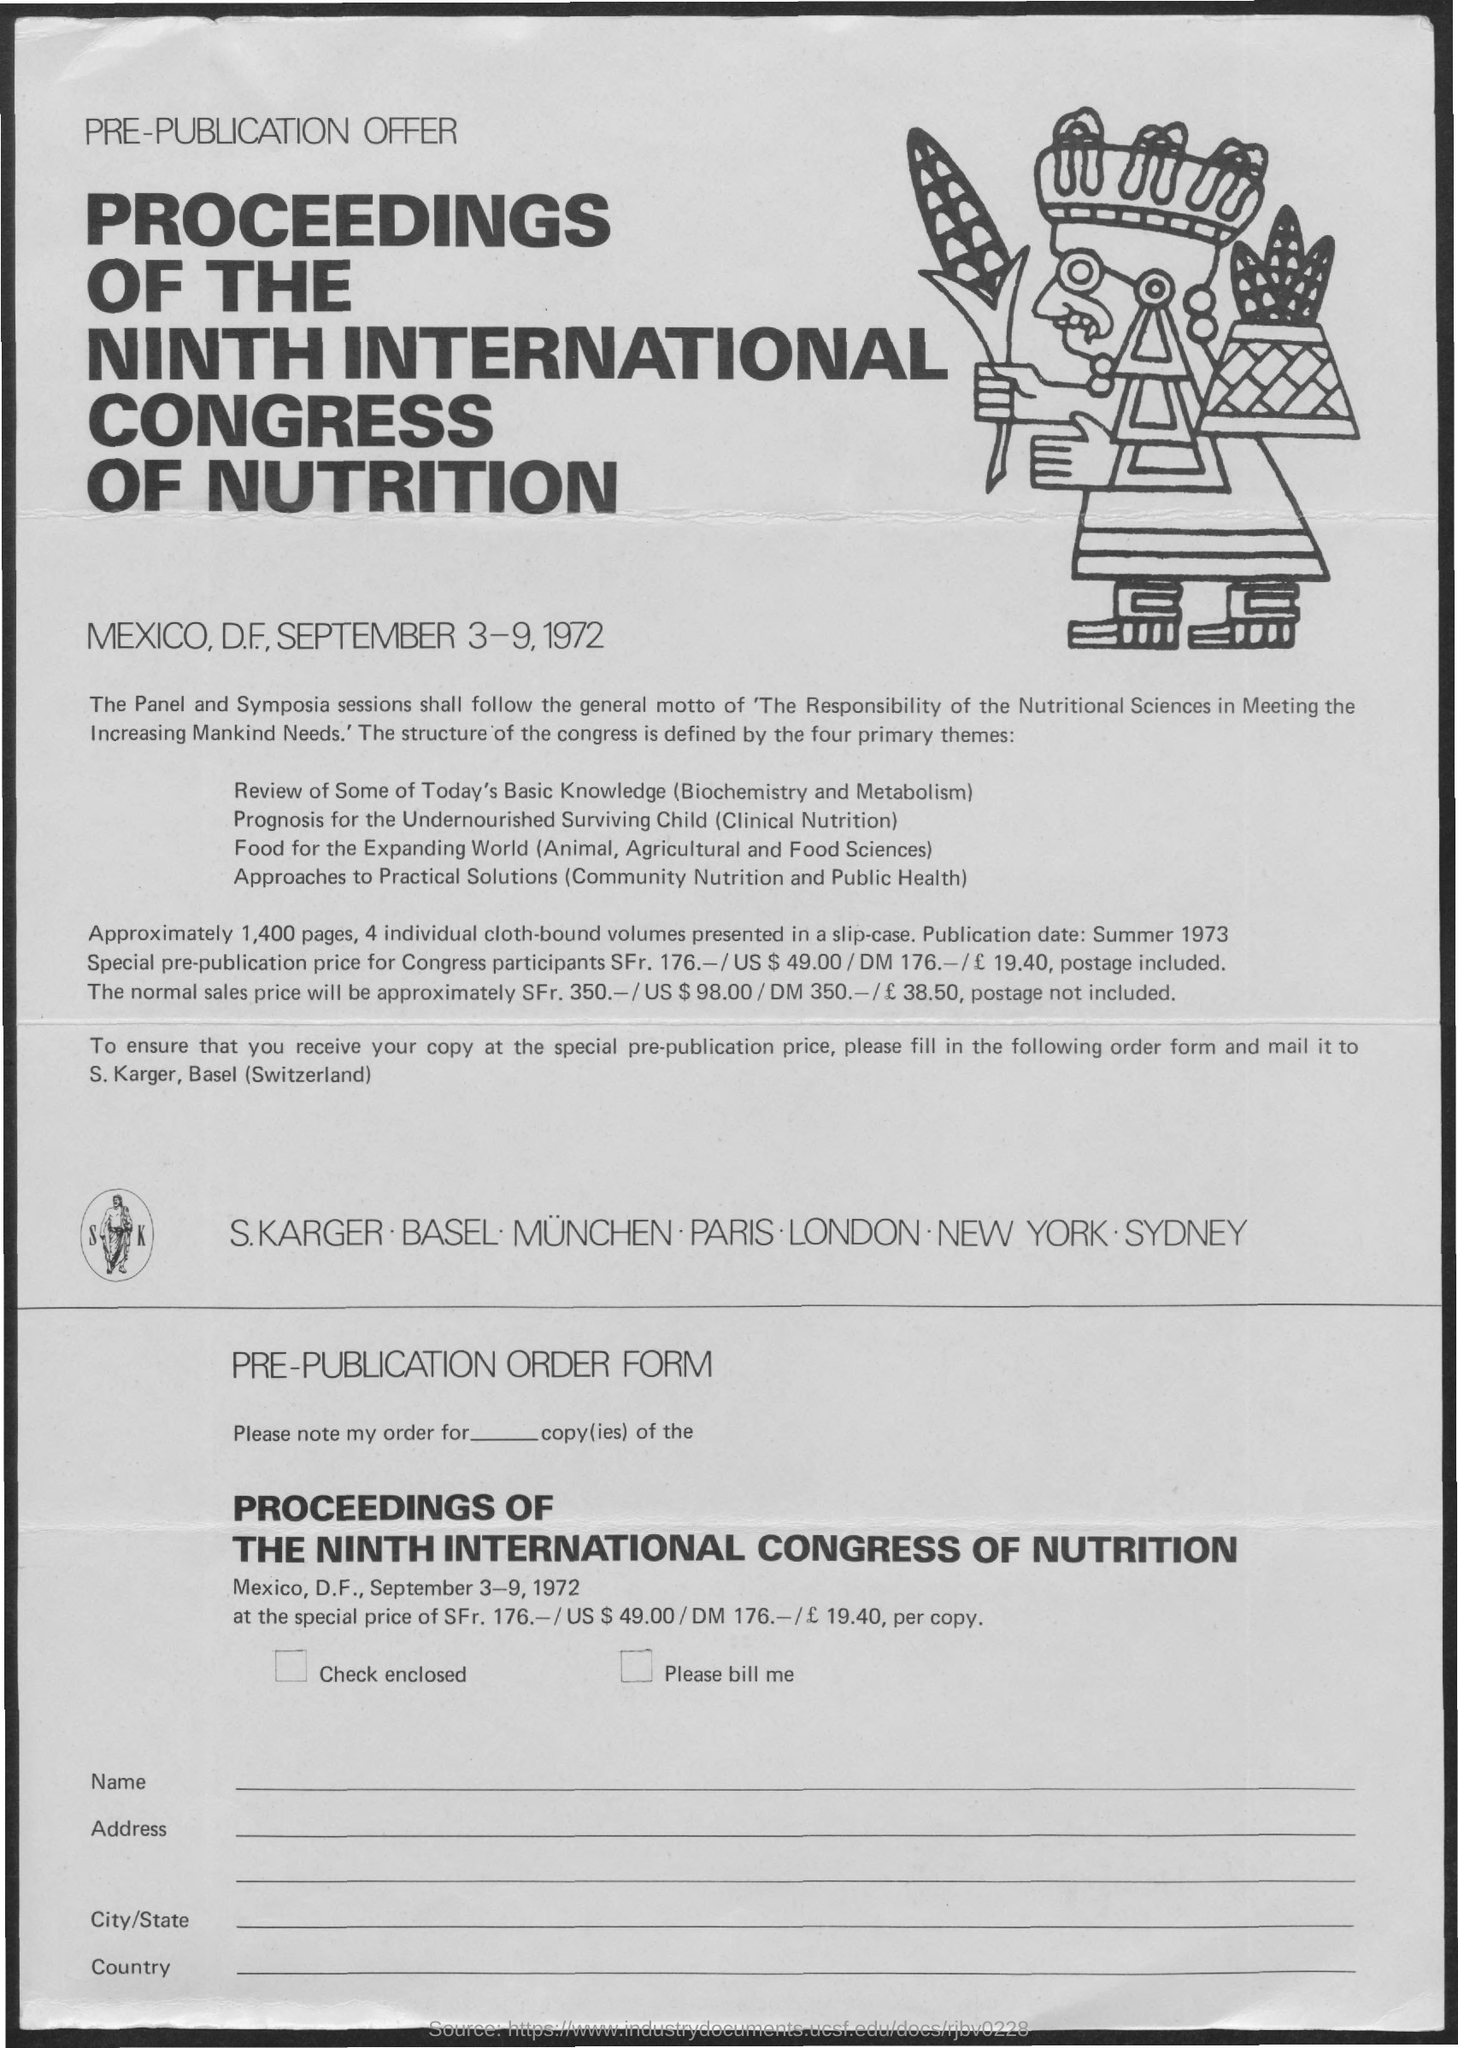When is the Proceedings of the Ninth International Congress of Nutrition?
Provide a succinct answer. September 3-9, 1972. Where was Ninth International Congress of Nutrition held?
Offer a terse response. Mexico, D.F. How many pages are the proceedings?
Provide a succinct answer. 1,400. How many cloth bound Volumes?
Provide a short and direct response. 4. What is the Publication Date?
Make the answer very short. Summer 1973. Where should the order form be mailed to?
Keep it short and to the point. S. Karger, Basel (Switzerland). 